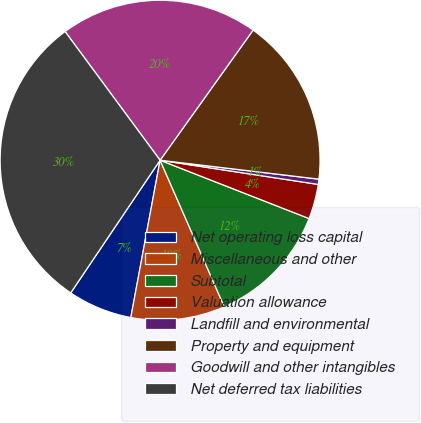Convert chart. <chart><loc_0><loc_0><loc_500><loc_500><pie_chart><fcel>Net operating loss capital<fcel>Miscellaneous and other<fcel>Subtotal<fcel>Valuation allowance<fcel>Landfill and environmental<fcel>Property and equipment<fcel>Goodwill and other intangibles<fcel>Net deferred tax liabilities<nl><fcel>6.51%<fcel>9.5%<fcel>12.49%<fcel>3.52%<fcel>0.53%<fcel>17.01%<fcel>20.0%<fcel>30.44%<nl></chart> 